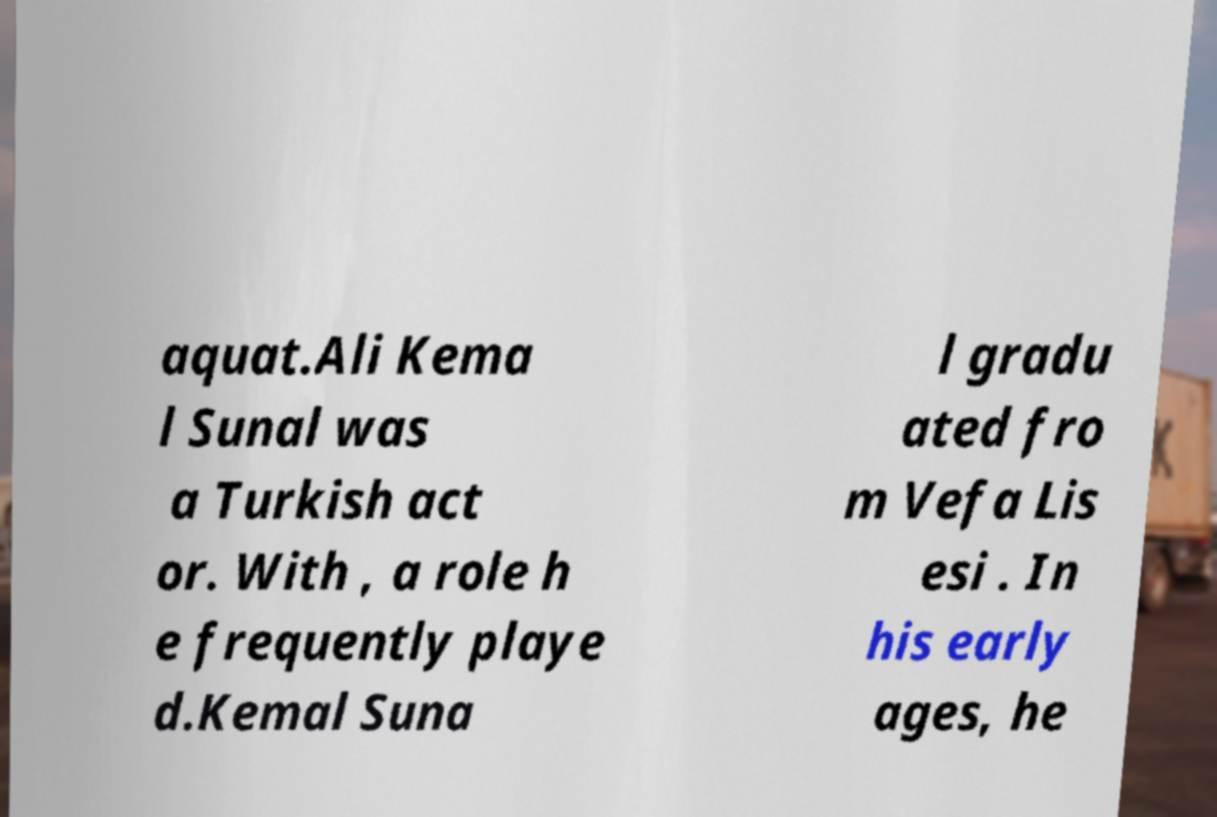For documentation purposes, I need the text within this image transcribed. Could you provide that? aquat.Ali Kema l Sunal was a Turkish act or. With , a role h e frequently playe d.Kemal Suna l gradu ated fro m Vefa Lis esi . In his early ages, he 